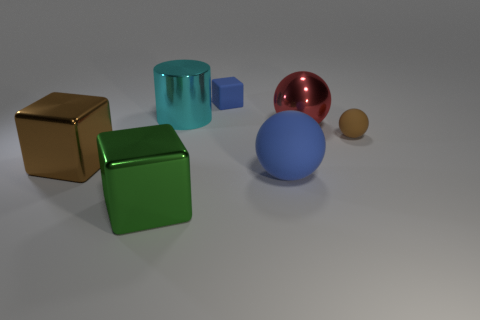Add 3 rubber objects. How many objects exist? 10 Subtract all big shiny balls. How many balls are left? 2 Subtract all blue blocks. How many blocks are left? 2 Subtract 1 cyan cylinders. How many objects are left? 6 Subtract all cylinders. How many objects are left? 6 Subtract 2 blocks. How many blocks are left? 1 Subtract all gray cylinders. Subtract all yellow blocks. How many cylinders are left? 1 Subtract all cyan balls. How many red cylinders are left? 0 Subtract all small brown matte cylinders. Subtract all cylinders. How many objects are left? 6 Add 2 rubber objects. How many rubber objects are left? 5 